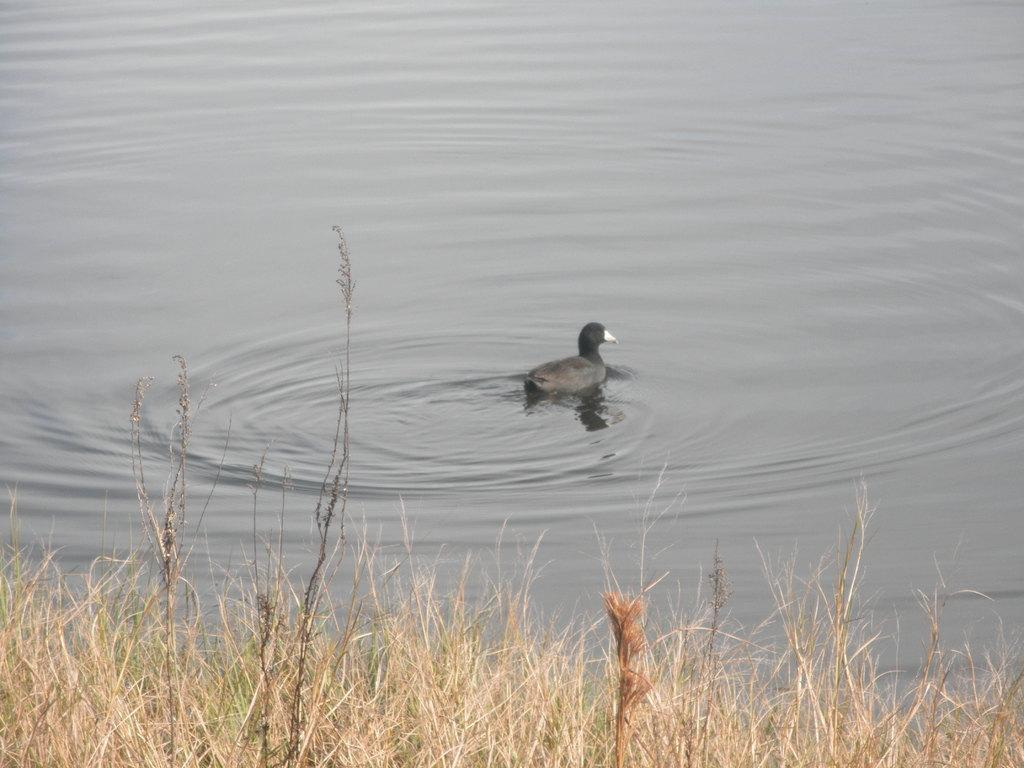What type of vegetation can be seen in the front of the image? There is grass in the front of the image. What can be seen in the background of the image? There is water visible in the background of the image. What is the main subject in the center of the image? There is a black color bird in the center of the image. Where is the bird located in relation to the water? The bird is on the water. Can you see a map in the image? There is no map present in the image. Is the bird holding a hook in the image? There is no hook present in the image, and the bird is not holding anything. 